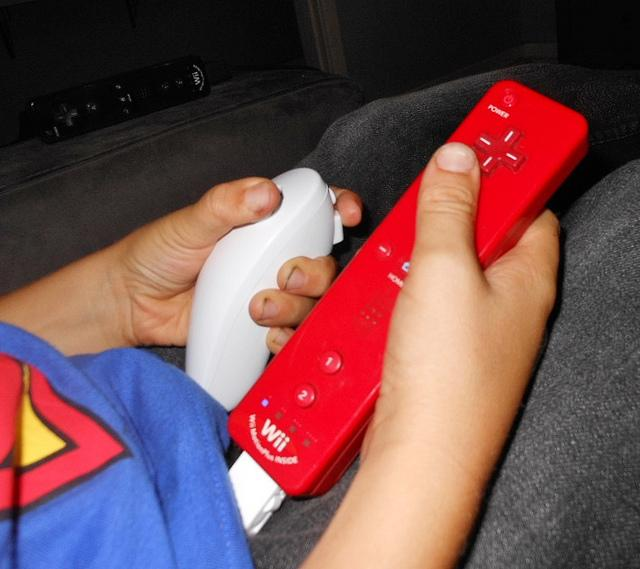How many players can play? Please explain your reasoning. two. There are two players. 